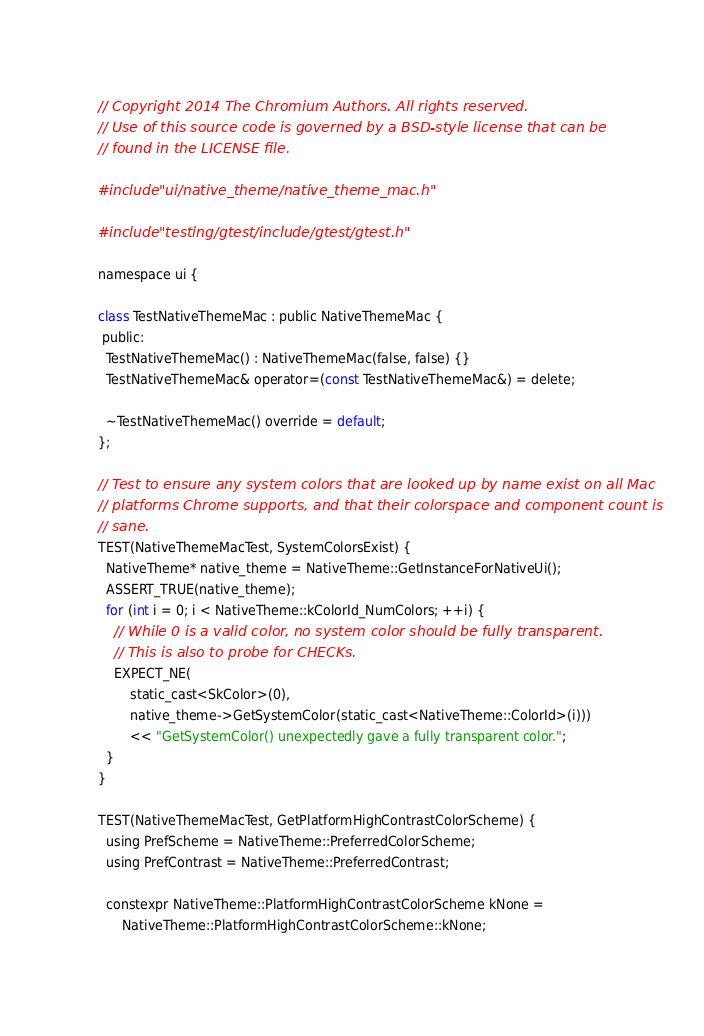<code> <loc_0><loc_0><loc_500><loc_500><_ObjectiveC_>// Copyright 2014 The Chromium Authors. All rights reserved.
// Use of this source code is governed by a BSD-style license that can be
// found in the LICENSE file.

#include "ui/native_theme/native_theme_mac.h"

#include "testing/gtest/include/gtest/gtest.h"

namespace ui {

class TestNativeThemeMac : public NativeThemeMac {
 public:
  TestNativeThemeMac() : NativeThemeMac(false, false) {}
  TestNativeThemeMac& operator=(const TestNativeThemeMac&) = delete;

  ~TestNativeThemeMac() override = default;
};

// Test to ensure any system colors that are looked up by name exist on all Mac
// platforms Chrome supports, and that their colorspace and component count is
// sane.
TEST(NativeThemeMacTest, SystemColorsExist) {
  NativeTheme* native_theme = NativeTheme::GetInstanceForNativeUi();
  ASSERT_TRUE(native_theme);
  for (int i = 0; i < NativeTheme::kColorId_NumColors; ++i) {
    // While 0 is a valid color, no system color should be fully transparent.
    // This is also to probe for CHECKs.
    EXPECT_NE(
        static_cast<SkColor>(0),
        native_theme->GetSystemColor(static_cast<NativeTheme::ColorId>(i)))
        << "GetSystemColor() unexpectedly gave a fully transparent color.";
  }
}

TEST(NativeThemeMacTest, GetPlatformHighContrastColorScheme) {
  using PrefScheme = NativeTheme::PreferredColorScheme;
  using PrefContrast = NativeTheme::PreferredContrast;

  constexpr NativeTheme::PlatformHighContrastColorScheme kNone =
      NativeTheme::PlatformHighContrastColorScheme::kNone;
</code> 